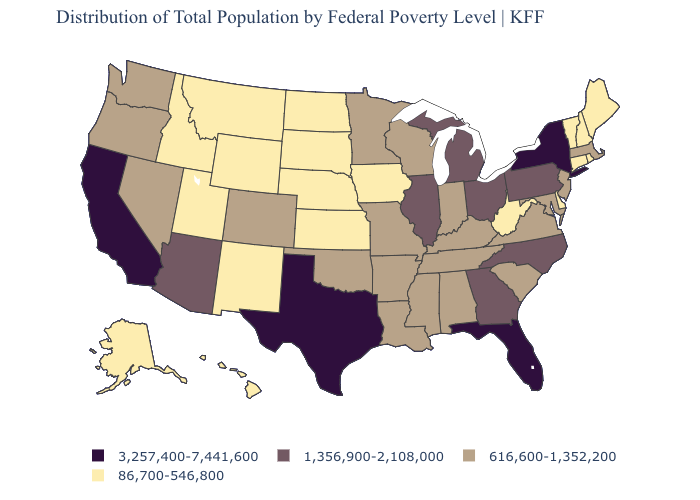Does Mississippi have the same value as Arizona?
Give a very brief answer. No. What is the highest value in the MidWest ?
Be succinct. 1,356,900-2,108,000. Does the first symbol in the legend represent the smallest category?
Short answer required. No. Among the states that border Nebraska , does Kansas have the lowest value?
Concise answer only. Yes. Does New Mexico have a lower value than Virginia?
Concise answer only. Yes. Which states have the lowest value in the USA?
Answer briefly. Alaska, Connecticut, Delaware, Hawaii, Idaho, Iowa, Kansas, Maine, Montana, Nebraska, New Hampshire, New Mexico, North Dakota, Rhode Island, South Dakota, Utah, Vermont, West Virginia, Wyoming. What is the lowest value in the USA?
Write a very short answer. 86,700-546,800. Name the states that have a value in the range 86,700-546,800?
Write a very short answer. Alaska, Connecticut, Delaware, Hawaii, Idaho, Iowa, Kansas, Maine, Montana, Nebraska, New Hampshire, New Mexico, North Dakota, Rhode Island, South Dakota, Utah, Vermont, West Virginia, Wyoming. Name the states that have a value in the range 86,700-546,800?
Be succinct. Alaska, Connecticut, Delaware, Hawaii, Idaho, Iowa, Kansas, Maine, Montana, Nebraska, New Hampshire, New Mexico, North Dakota, Rhode Island, South Dakota, Utah, Vermont, West Virginia, Wyoming. Does Georgia have a higher value than Florida?
Answer briefly. No. Does the first symbol in the legend represent the smallest category?
Short answer required. No. How many symbols are there in the legend?
Answer briefly. 4. What is the value of Iowa?
Be succinct. 86,700-546,800. What is the lowest value in the USA?
Keep it brief. 86,700-546,800. Name the states that have a value in the range 3,257,400-7,441,600?
Give a very brief answer. California, Florida, New York, Texas. 